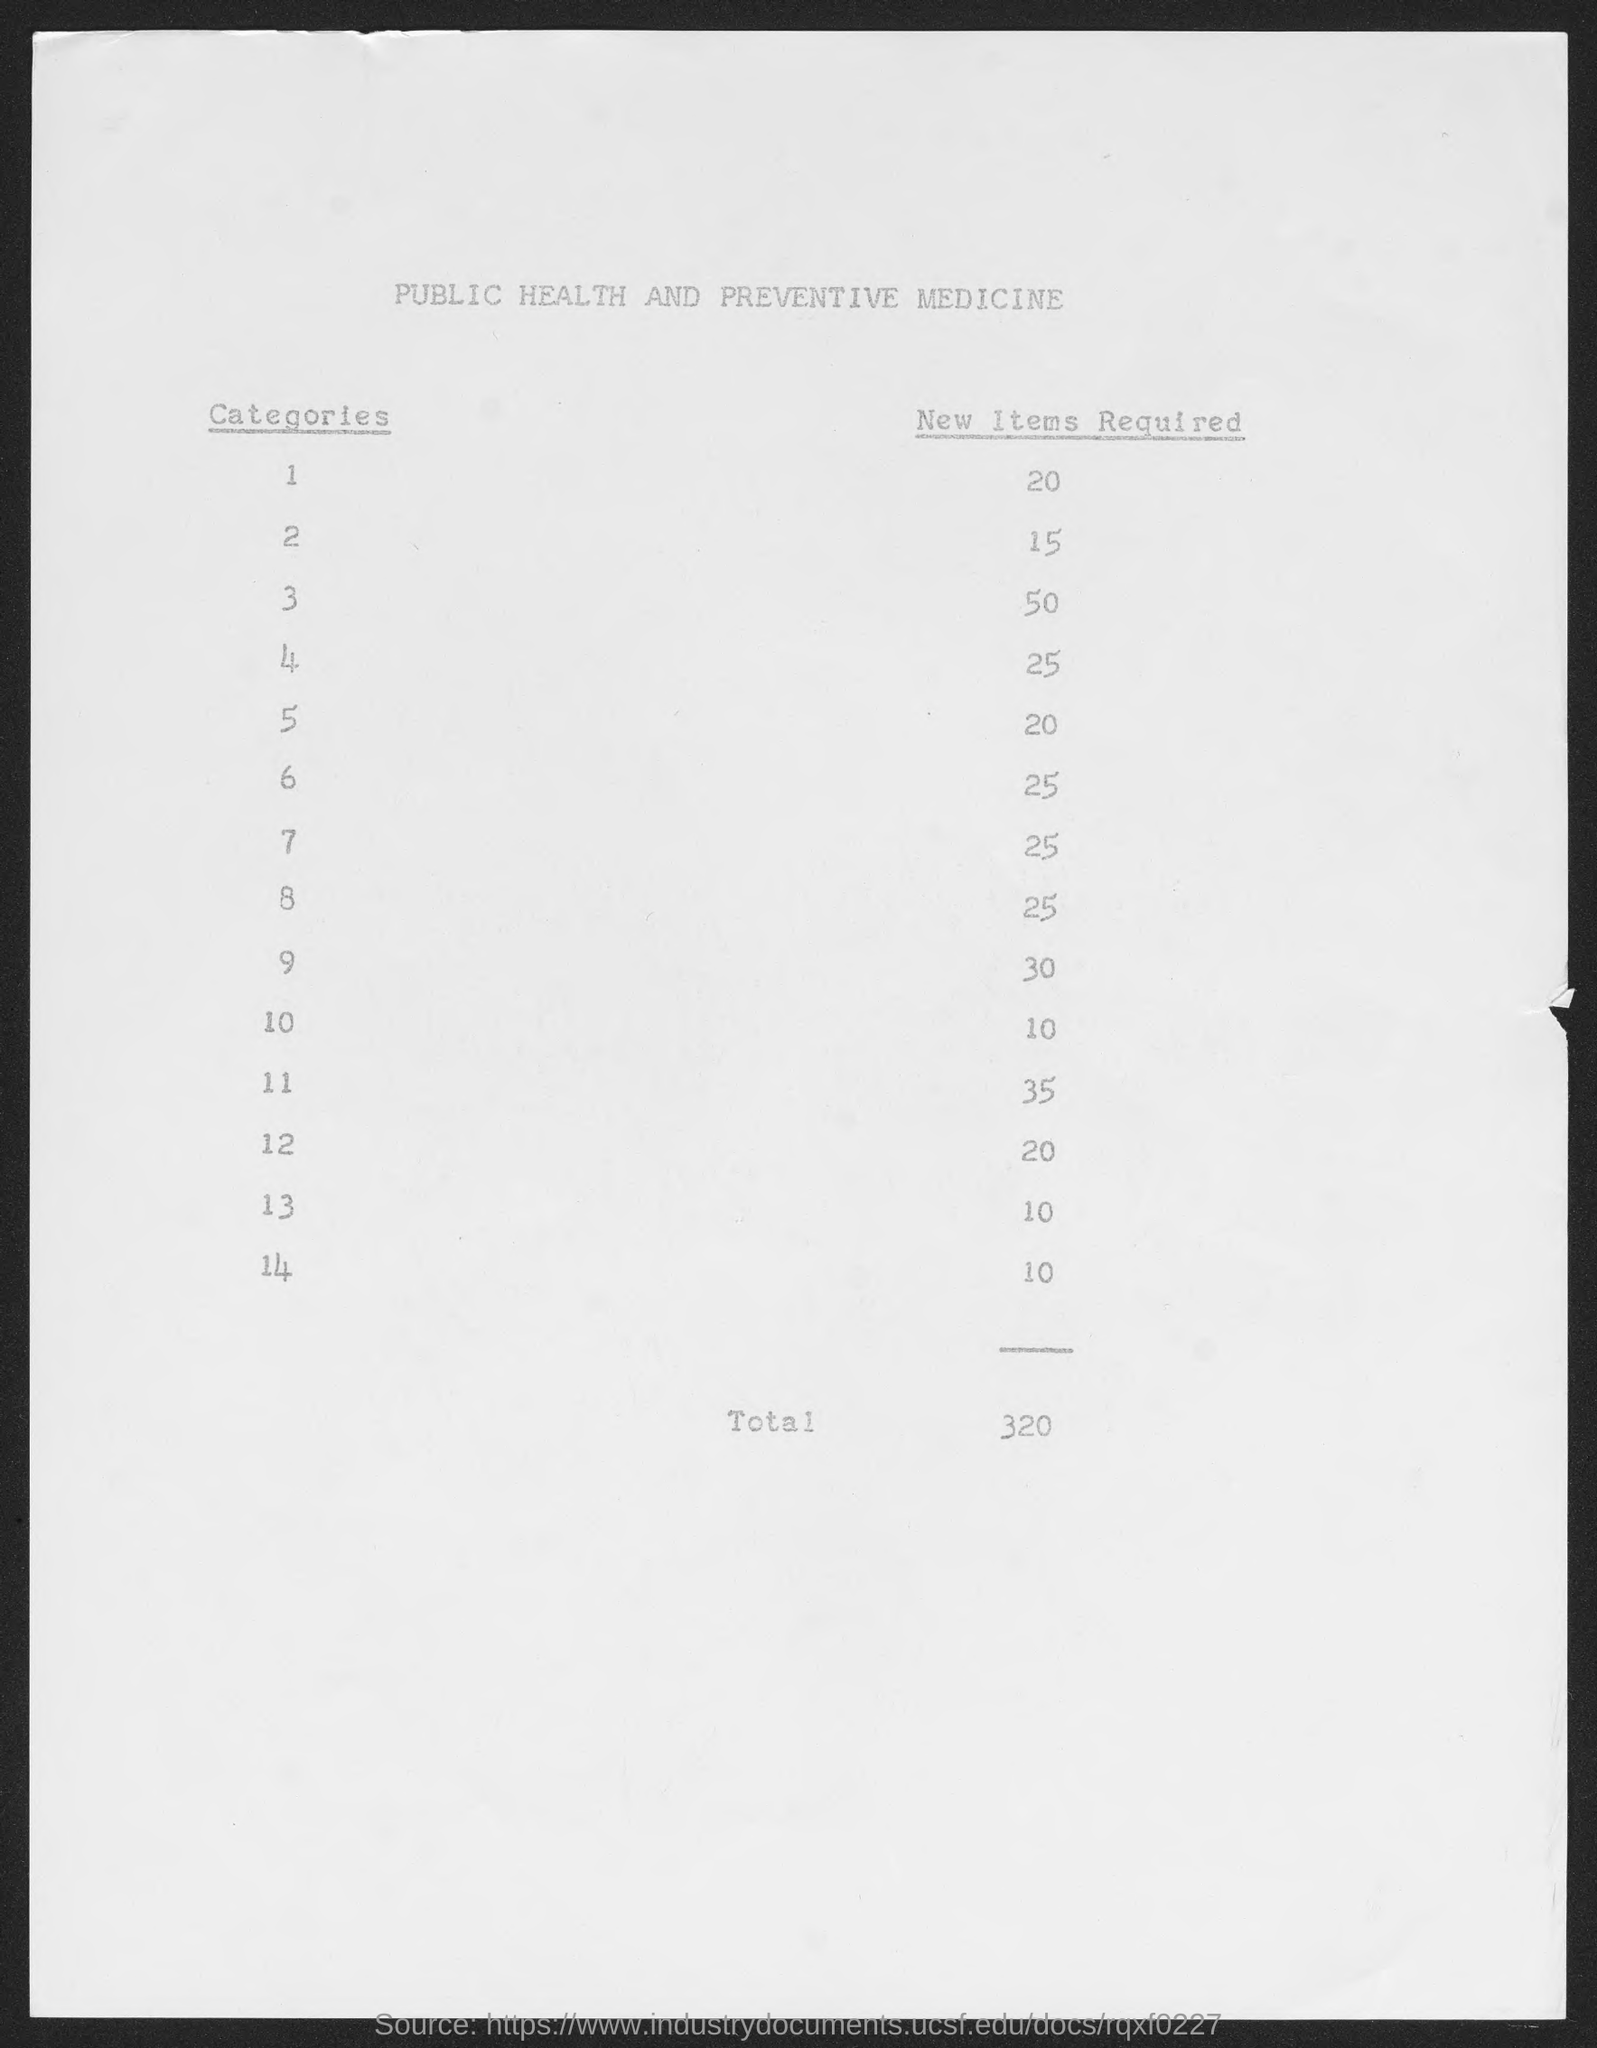What is the title of the document?
Offer a very short reply. Public Health and Preventive medicine. How many numbers of  total new items required?
Ensure brevity in your answer.  320. How many categories are there?
Your answer should be compact. 14. 